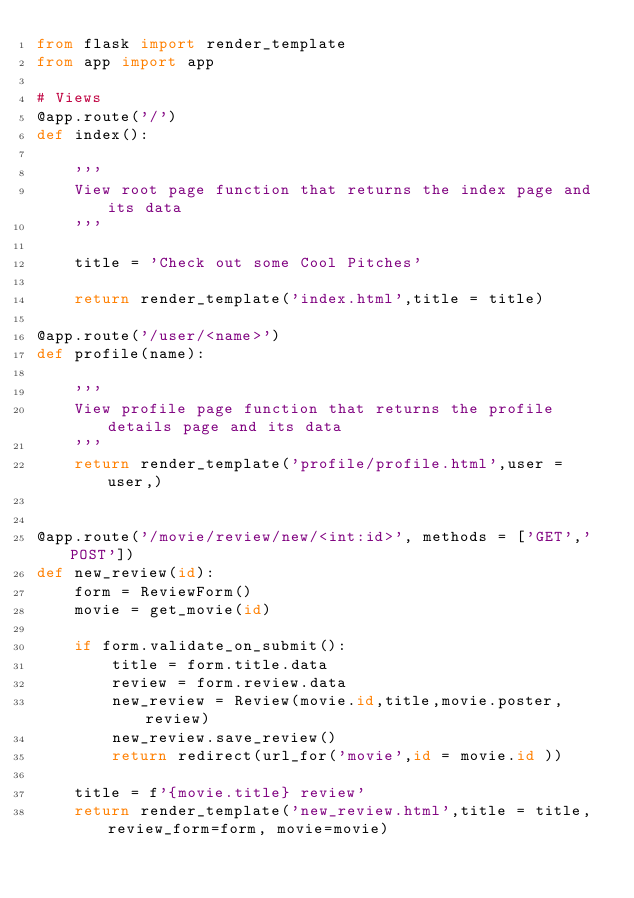<code> <loc_0><loc_0><loc_500><loc_500><_Python_>from flask import render_template
from app import app

# Views
@app.route('/')
def index():

    '''
    View root page function that returns the index page and its data
    '''

    title = 'Check out some Cool Pitches'
    
    return render_template('index.html',title = title)

@app.route('/user/<name>')
def profile(name):

    '''
    View profile page function that returns the profile details page and its data
    '''
    return render_template('profile/profile.html',user = user,)


@app.route('/movie/review/new/<int:id>', methods = ['GET','POST'])
def new_review(id):
    form = ReviewForm()
    movie = get_movie(id)

    if form.validate_on_submit():
        title = form.title.data
        review = form.review.data
        new_review = Review(movie.id,title,movie.poster,review)
        new_review.save_review()
        return redirect(url_for('movie',id = movie.id ))

    title = f'{movie.title} review'
    return render_template('new_review.html',title = title, review_form=form, movie=movie)
</code> 